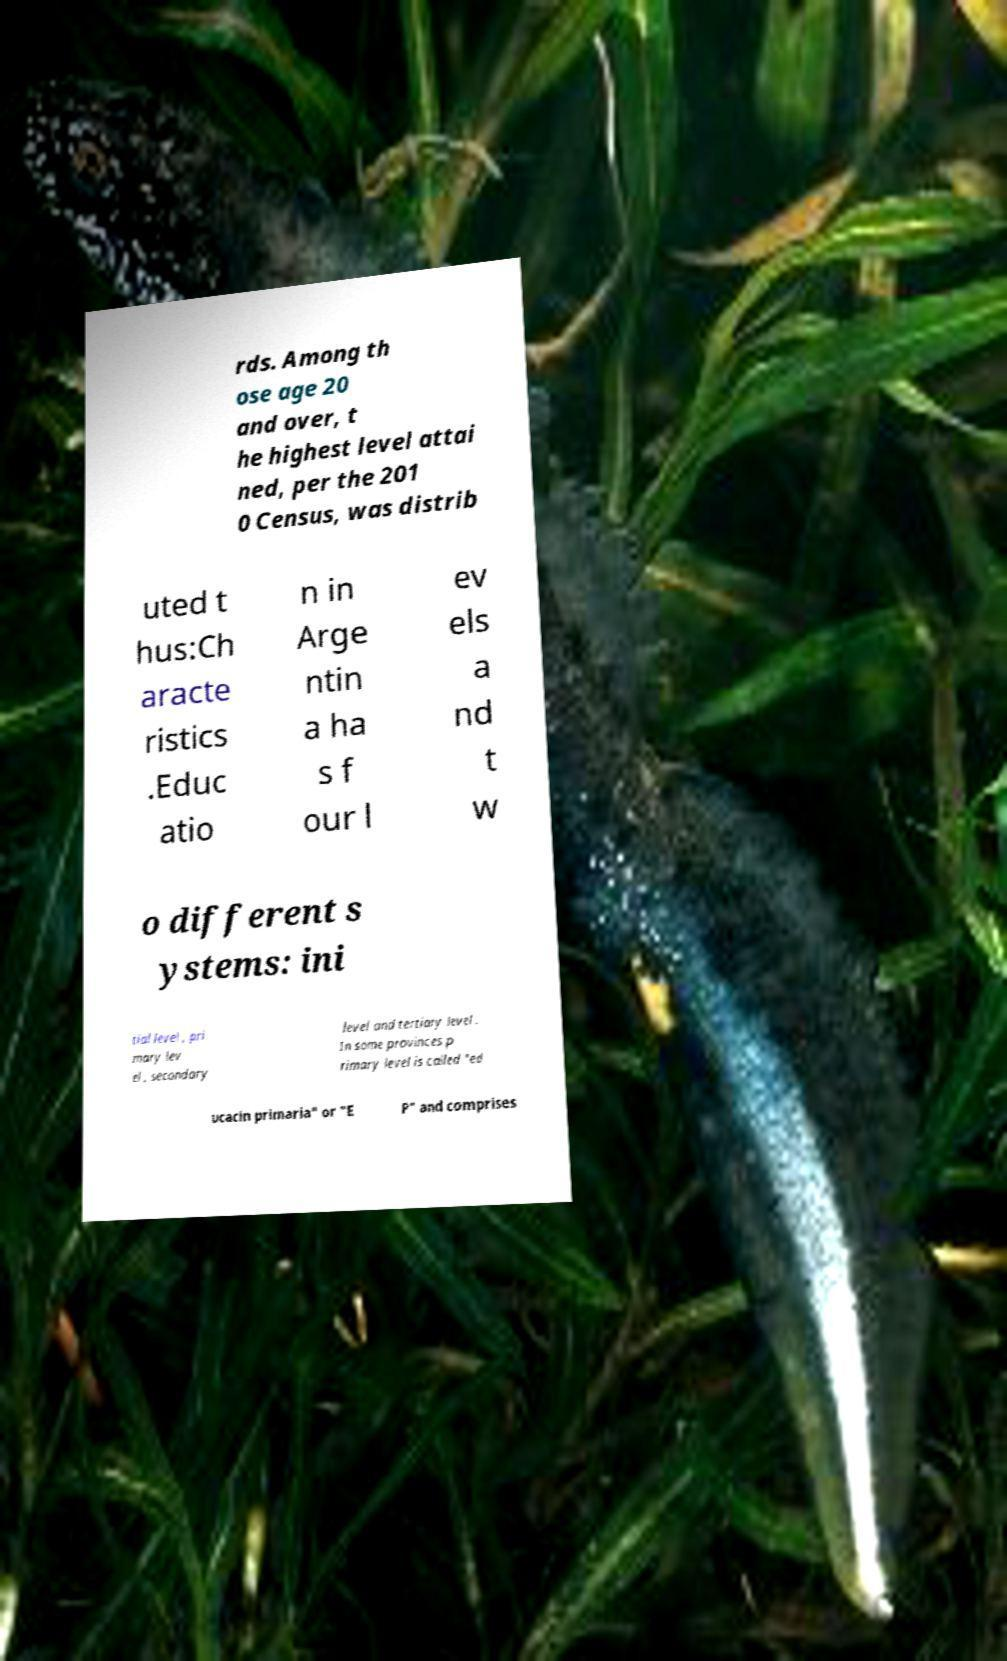There's text embedded in this image that I need extracted. Can you transcribe it verbatim? rds. Among th ose age 20 and over, t he highest level attai ned, per the 201 0 Census, was distrib uted t hus:Ch aracte ristics .Educ atio n in Arge ntin a ha s f our l ev els a nd t w o different s ystems: ini tial level , pri mary lev el , secondary level and tertiary level . In some provinces p rimary level is called "ed ucacin primaria" or "E P" and comprises 